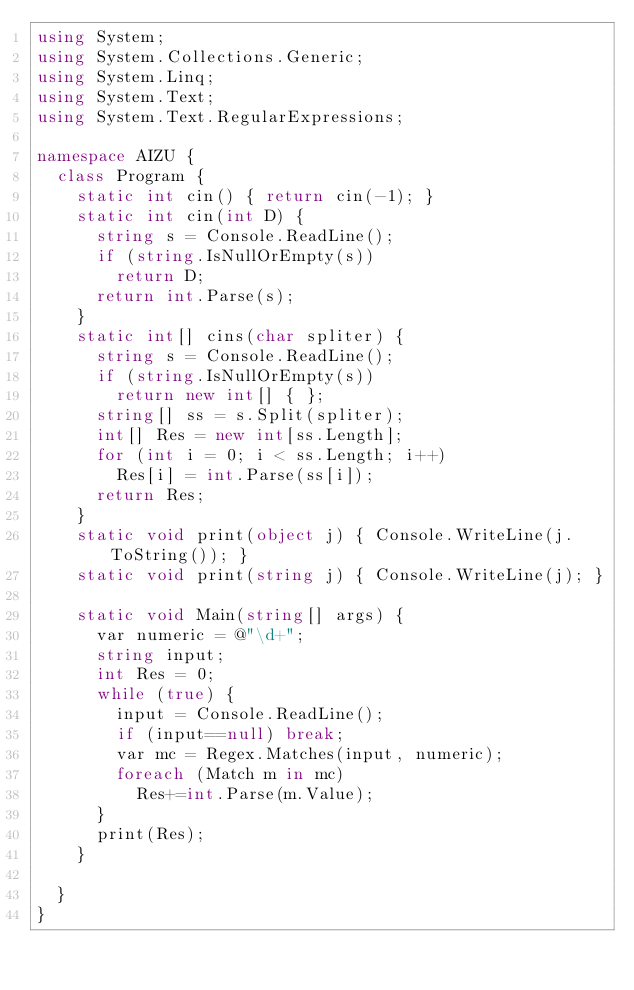Convert code to text. <code><loc_0><loc_0><loc_500><loc_500><_C#_>using System;
using System.Collections.Generic;
using System.Linq;
using System.Text;
using System.Text.RegularExpressions;

namespace AIZU {
	class Program {
		static int cin() { return cin(-1); }
		static int cin(int D) {
			string s = Console.ReadLine();
			if (string.IsNullOrEmpty(s))
				return D;
			return int.Parse(s);
		}
		static int[] cins(char spliter) {
			string s = Console.ReadLine();
			if (string.IsNullOrEmpty(s))
				return new int[] { };
			string[] ss = s.Split(spliter);
			int[] Res = new int[ss.Length];
			for (int i = 0; i < ss.Length; i++)
				Res[i] = int.Parse(ss[i]);
			return Res;
		}
		static void print(object j) { Console.WriteLine(j.ToString()); }
		static void print(string j) { Console.WriteLine(j); }

		static void Main(string[] args) {
			var numeric = @"\d+";
			string input;
			int Res = 0;
			while (true) {
				input = Console.ReadLine();
				if (input==null) break;
				var mc = Regex.Matches(input, numeric);
				foreach (Match m in mc) 
					Res+=int.Parse(m.Value);
			}
			print(Res);
		}
		
	}
}</code> 